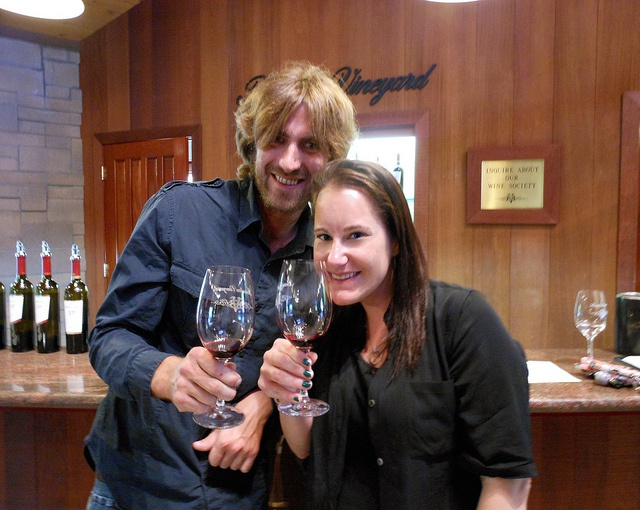Describe the objects in this image and their specific colors. I can see people in white, black, gray, navy, and brown tones, people in white, black, brown, gray, and lightpink tones, dining table in white, black, maroon, and tan tones, wine glass in white, gray, darkgray, and black tones, and wine glass in white, gray, black, brown, and darkgray tones in this image. 